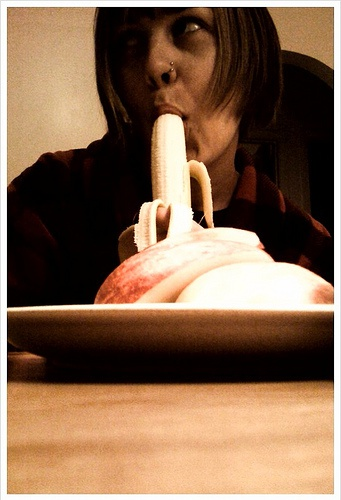Describe the objects in this image and their specific colors. I can see people in lightgray, black, maroon, brown, and red tones, apple in lightgray, beige, tan, salmon, and red tones, banana in lightgray, beige, tan, and brown tones, and apple in lightgray, beige, tan, black, and salmon tones in this image. 